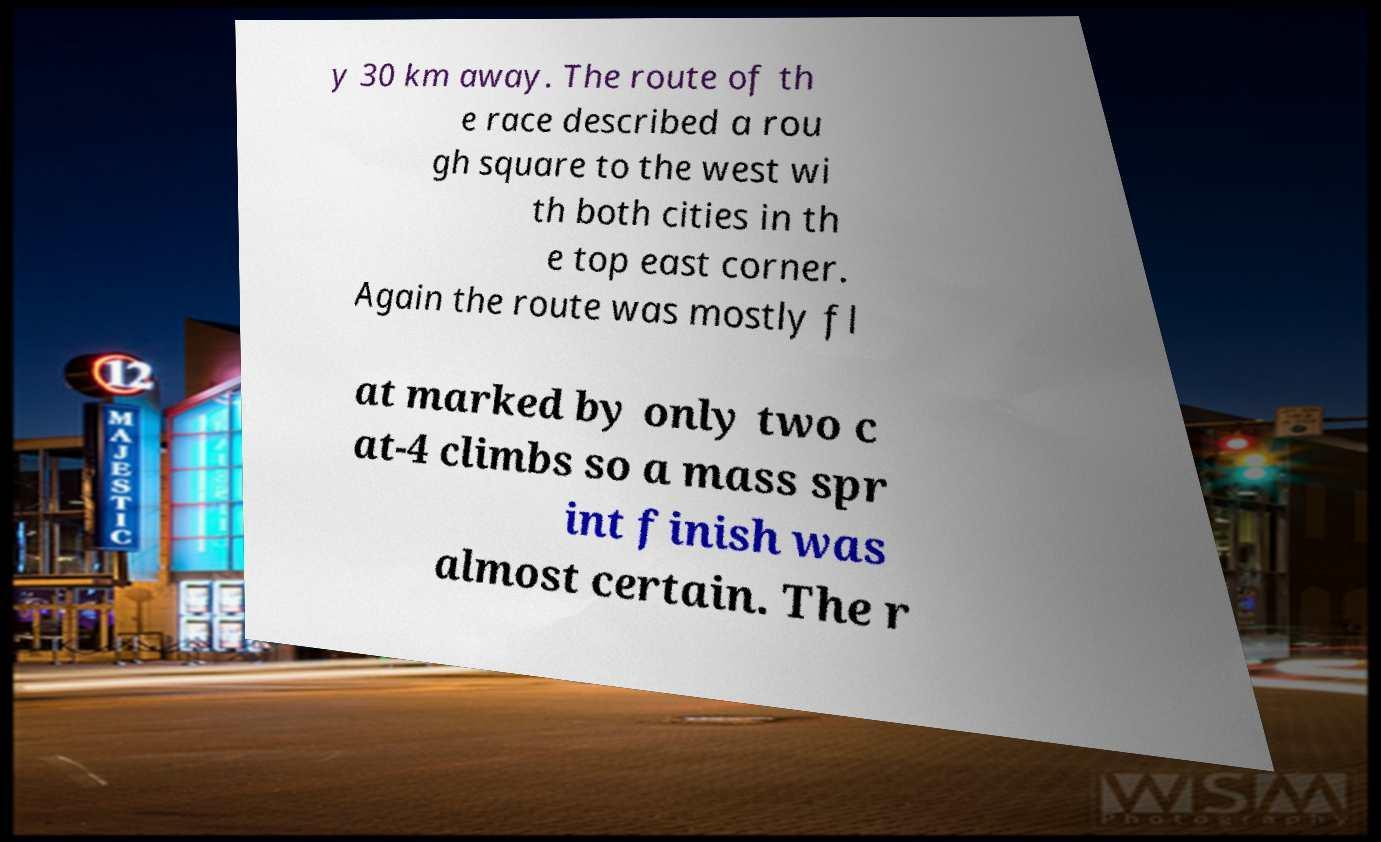Can you accurately transcribe the text from the provided image for me? y 30 km away. The route of th e race described a rou gh square to the west wi th both cities in th e top east corner. Again the route was mostly fl at marked by only two c at-4 climbs so a mass spr int finish was almost certain. The r 